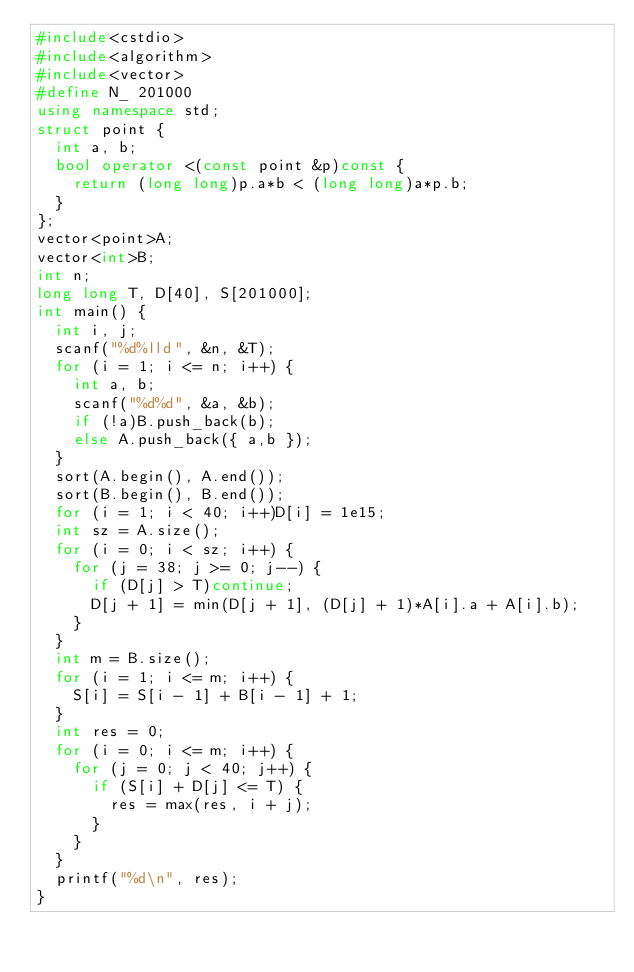<code> <loc_0><loc_0><loc_500><loc_500><_C++_>#include<cstdio>
#include<algorithm>
#include<vector>
#define N_ 201000
using namespace std;
struct point {
	int a, b;
	bool operator <(const point &p)const {
		return (long long)p.a*b < (long long)a*p.b;
	}
};
vector<point>A;
vector<int>B;
int n;
long long T, D[40], S[201000];
int main() {
	int i, j;
	scanf("%d%lld", &n, &T);
	for (i = 1; i <= n; i++) {
		int a, b;
		scanf("%d%d", &a, &b);
		if (!a)B.push_back(b);
		else A.push_back({ a,b });
	}
	sort(A.begin(), A.end());
	sort(B.begin(), B.end());
	for (i = 1; i < 40; i++)D[i] = 1e15;
	int sz = A.size();
	for (i = 0; i < sz; i++) {
		for (j = 38; j >= 0; j--) {	
			if (D[j] > T)continue;
			D[j + 1] = min(D[j + 1], (D[j] + 1)*A[i].a + A[i].b);
		}
	}
	int m = B.size();
	for (i = 1; i <= m; i++) {
		S[i] = S[i - 1] + B[i - 1] + 1;
	}
	int res = 0;
	for (i = 0; i <= m; i++) {
		for (j = 0; j < 40; j++) {
			if (S[i] + D[j] <= T) {
				res = max(res, i + j);
			}
		}
	}
	printf("%d\n", res);
}</code> 